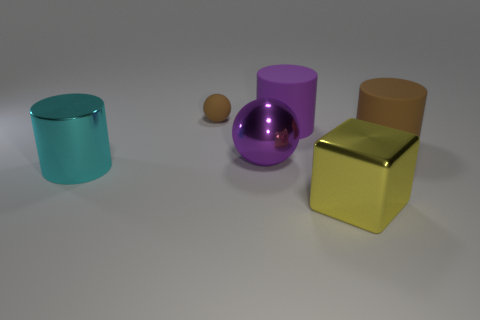Subtract all large purple rubber cylinders. How many cylinders are left? 2 Add 4 gray cylinders. How many objects exist? 10 Subtract all cubes. How many objects are left? 5 Subtract 1 cylinders. How many cylinders are left? 2 Add 1 shiny spheres. How many shiny spheres are left? 2 Add 5 big metallic blocks. How many big metallic blocks exist? 6 Subtract 0 green blocks. How many objects are left? 6 Subtract all yellow cylinders. Subtract all red spheres. How many cylinders are left? 3 Subtract all large cylinders. Subtract all big purple shiny balls. How many objects are left? 2 